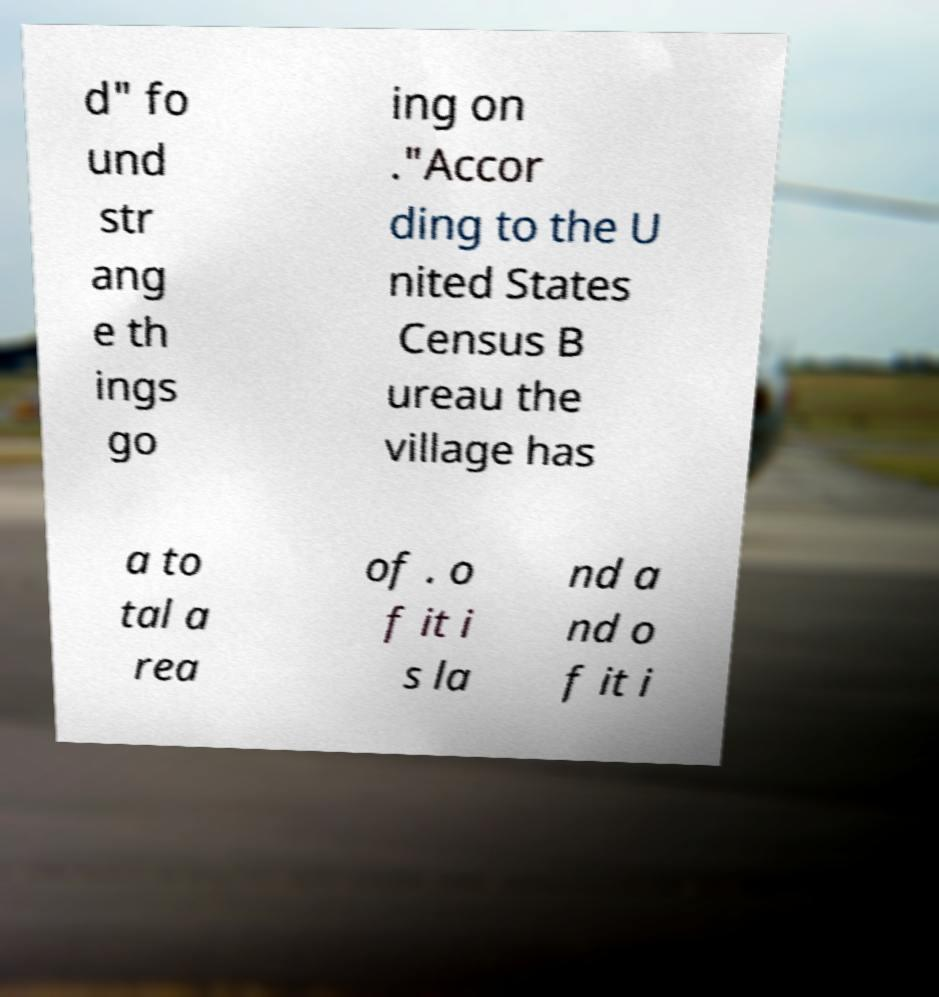Please read and relay the text visible in this image. What does it say? d" fo und str ang e th ings go ing on ."Accor ding to the U nited States Census B ureau the village has a to tal a rea of . o f it i s la nd a nd o f it i 